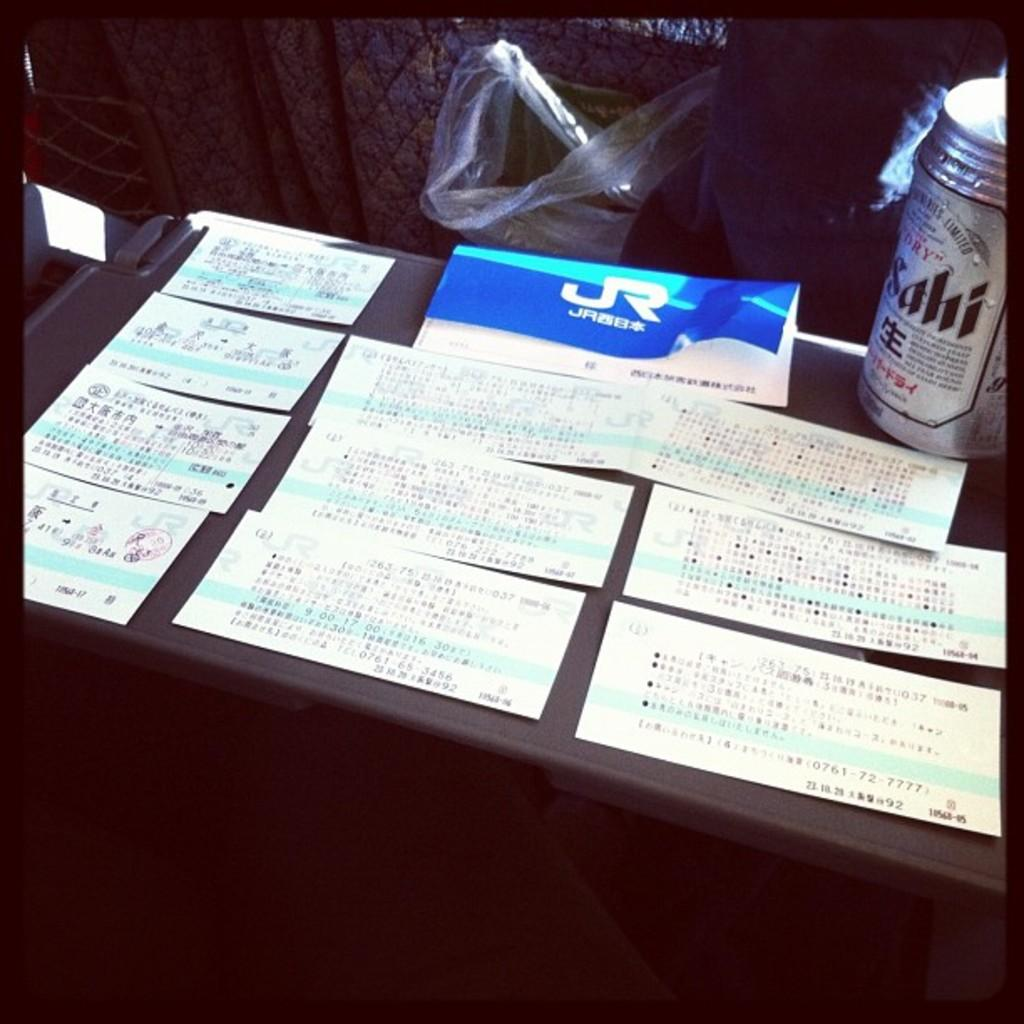<image>
Share a concise interpretation of the image provided. a series of train tickets beneath an envelope with JR on it next to a can of sahi beer 